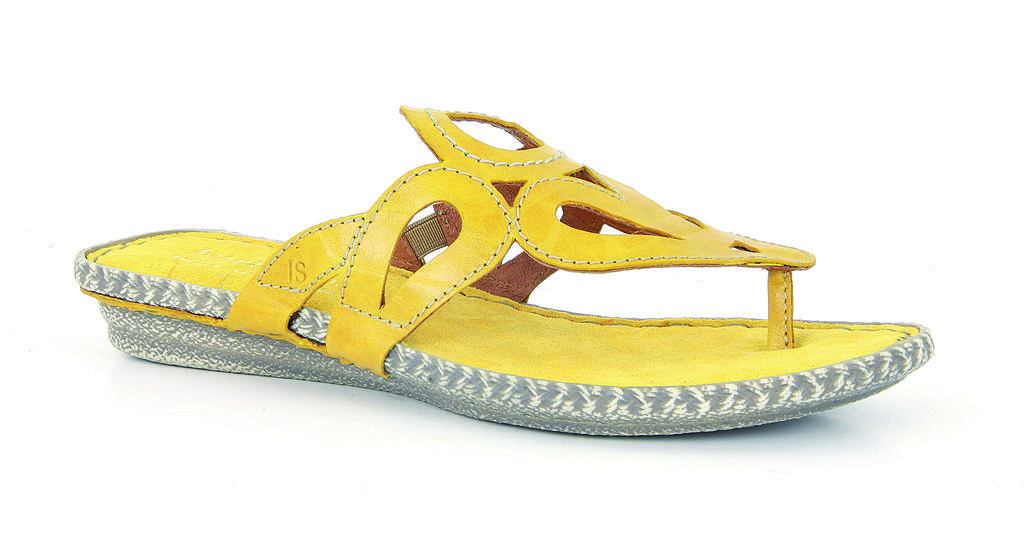How would you summarize this image in a sentence or two? In this image we can see a slipper. 